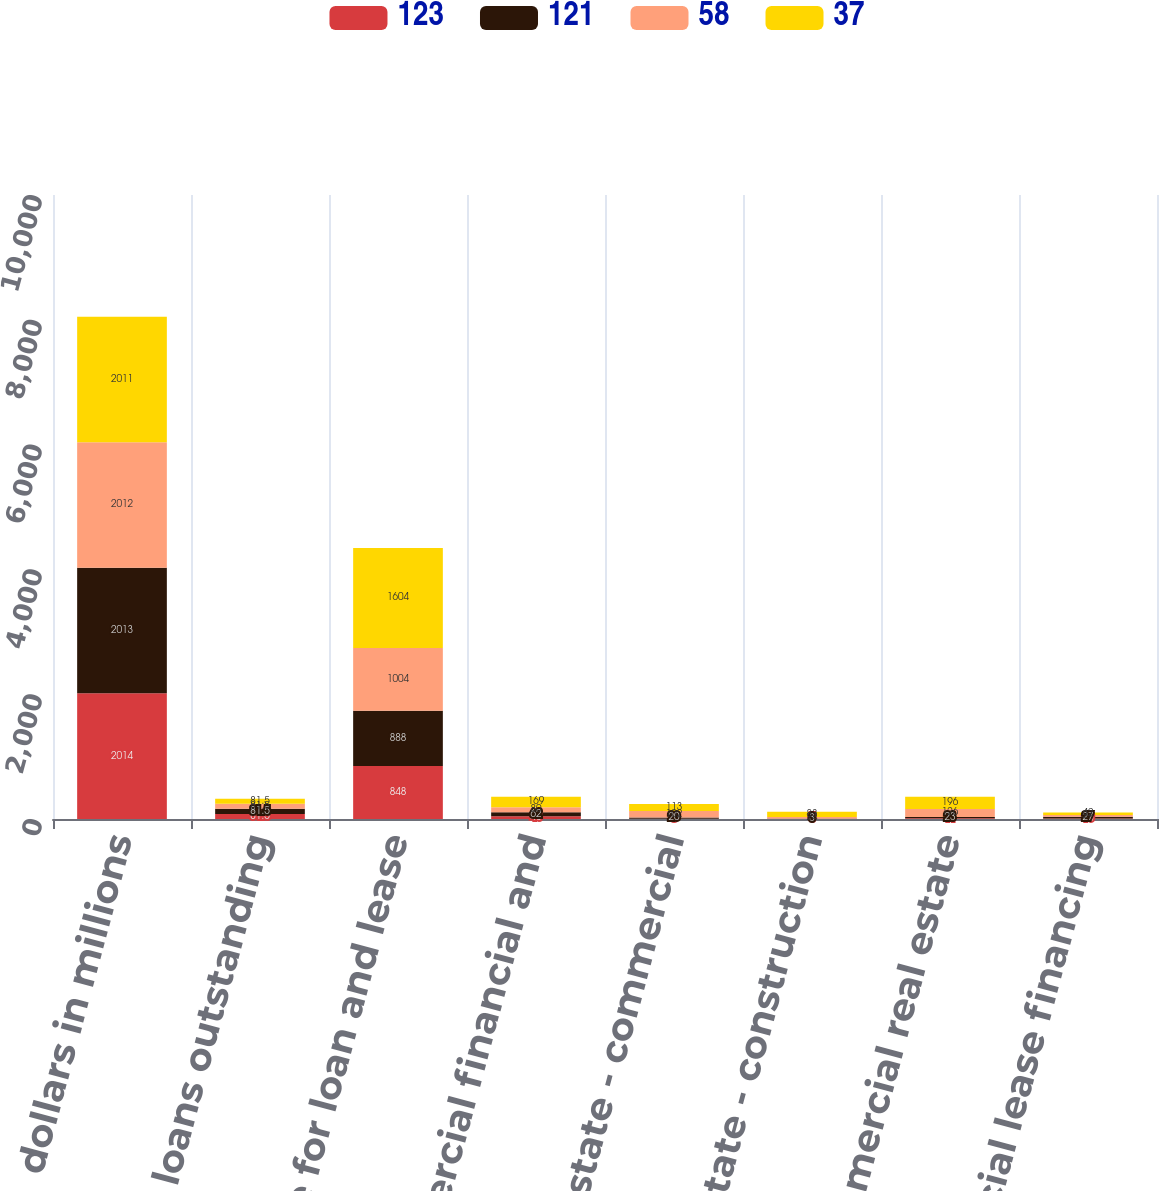<chart> <loc_0><loc_0><loc_500><loc_500><stacked_bar_chart><ecel><fcel>dollars in millions<fcel>Average loans outstanding<fcel>Allowance for loan and lease<fcel>Commercial financial and<fcel>Real estate - commercial<fcel>Real estate - construction<fcel>Total commercial real estate<fcel>Commercial lease financing<nl><fcel>123<fcel>2014<fcel>81.5<fcel>848<fcel>45<fcel>6<fcel>5<fcel>11<fcel>10<nl><fcel>121<fcel>2013<fcel>81.5<fcel>888<fcel>62<fcel>20<fcel>3<fcel>23<fcel>27<nl><fcel>58<fcel>2012<fcel>81.5<fcel>1004<fcel>80<fcel>102<fcel>24<fcel>126<fcel>27<nl><fcel>37<fcel>2011<fcel>81.5<fcel>1604<fcel>169<fcel>113<fcel>83<fcel>196<fcel>42<nl></chart> 